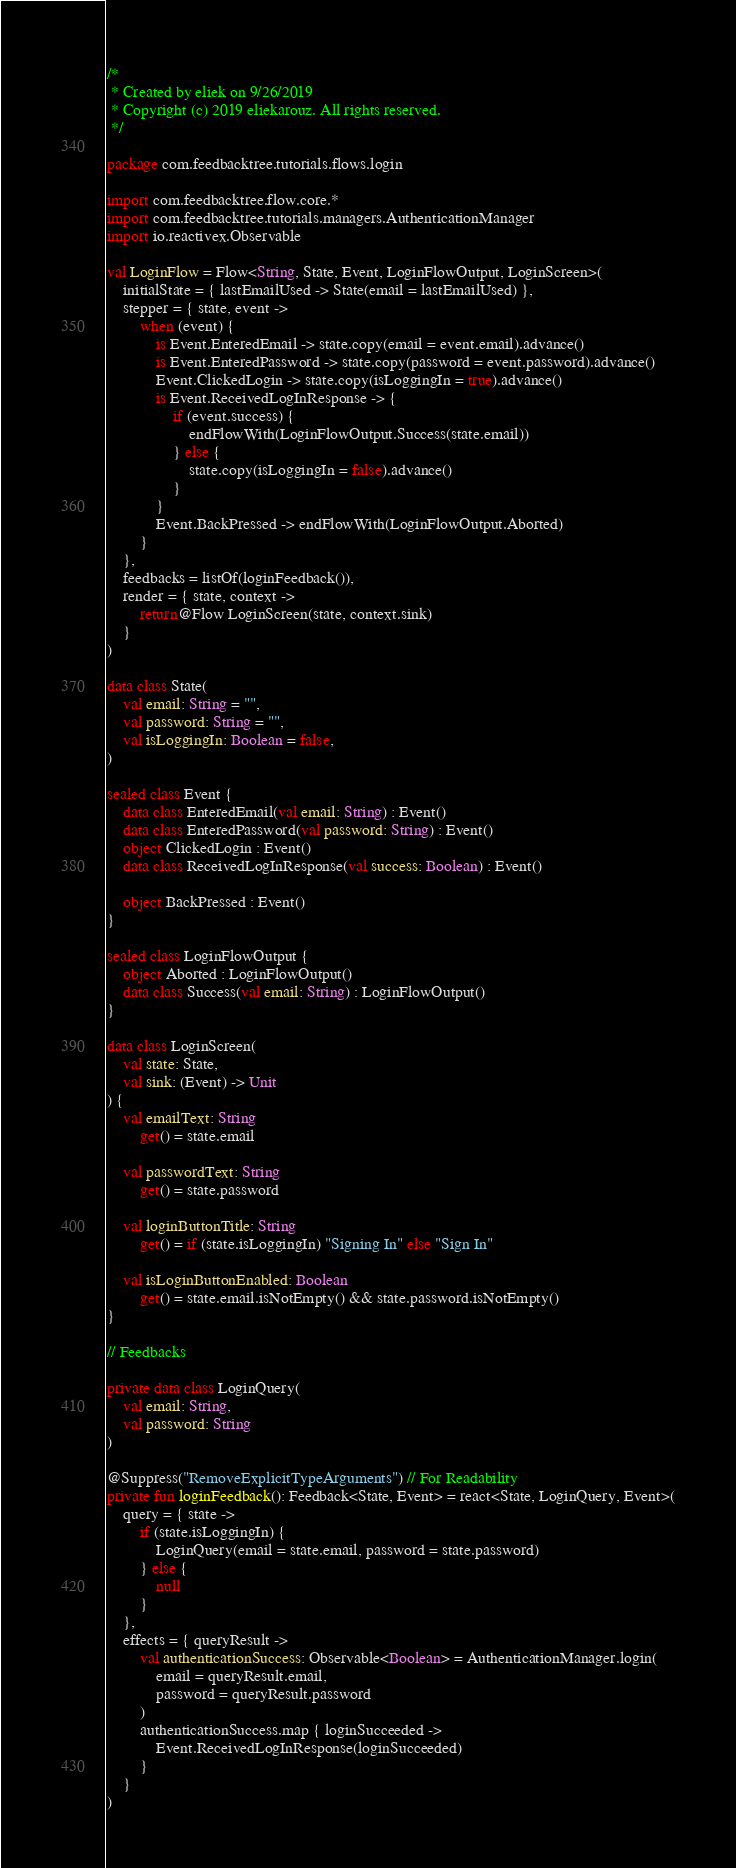Convert code to text. <code><loc_0><loc_0><loc_500><loc_500><_Kotlin_>/*
 * Created by eliek on 9/26/2019
 * Copyright (c) 2019 eliekarouz. All rights reserved.
 */

package com.feedbacktree.tutorials.flows.login

import com.feedbacktree.flow.core.*
import com.feedbacktree.tutorials.managers.AuthenticationManager
import io.reactivex.Observable

val LoginFlow = Flow<String, State, Event, LoginFlowOutput, LoginScreen>(
    initialState = { lastEmailUsed -> State(email = lastEmailUsed) },
    stepper = { state, event ->
        when (event) {
            is Event.EnteredEmail -> state.copy(email = event.email).advance()
            is Event.EnteredPassword -> state.copy(password = event.password).advance()
            Event.ClickedLogin -> state.copy(isLoggingIn = true).advance()
            is Event.ReceivedLogInResponse -> {
                if (event.success) {
                    endFlowWith(LoginFlowOutput.Success(state.email))
                } else {
                    state.copy(isLoggingIn = false).advance()
                }
            }
            Event.BackPressed -> endFlowWith(LoginFlowOutput.Aborted)
        }
    },
    feedbacks = listOf(loginFeedback()),
    render = { state, context ->
        return@Flow LoginScreen(state, context.sink)
    }
)

data class State(
    val email: String = "",
    val password: String = "",
    val isLoggingIn: Boolean = false,
)

sealed class Event {
    data class EnteredEmail(val email: String) : Event()
    data class EnteredPassword(val password: String) : Event()
    object ClickedLogin : Event()
    data class ReceivedLogInResponse(val success: Boolean) : Event()

    object BackPressed : Event()
}

sealed class LoginFlowOutput {
    object Aborted : LoginFlowOutput()
    data class Success(val email: String) : LoginFlowOutput()
}

data class LoginScreen(
    val state: State,
    val sink: (Event) -> Unit
) {
    val emailText: String
        get() = state.email

    val passwordText: String
        get() = state.password

    val loginButtonTitle: String
        get() = if (state.isLoggingIn) "Signing In" else "Sign In"

    val isLoginButtonEnabled: Boolean
        get() = state.email.isNotEmpty() && state.password.isNotEmpty()
}

// Feedbacks

private data class LoginQuery(
    val email: String,
    val password: String
)

@Suppress("RemoveExplicitTypeArguments") // For Readability
private fun loginFeedback(): Feedback<State, Event> = react<State, LoginQuery, Event>(
    query = { state ->
        if (state.isLoggingIn) {
            LoginQuery(email = state.email, password = state.password)
        } else {
            null
        }
    },
    effects = { queryResult ->
        val authenticationSuccess: Observable<Boolean> = AuthenticationManager.login(
            email = queryResult.email,
            password = queryResult.password
        )
        authenticationSuccess.map { loginSucceeded ->
            Event.ReceivedLogInResponse(loginSucceeded)
        }
    }
)
</code> 